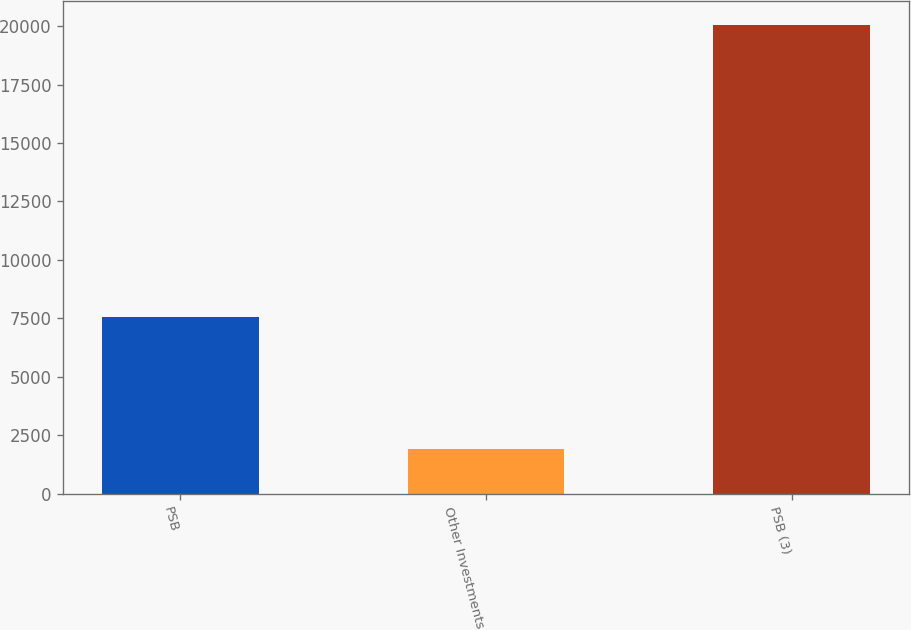Convert chart. <chart><loc_0><loc_0><loc_500><loc_500><bar_chart><fcel>PSB<fcel>Other Investments<fcel>PSB (3)<nl><fcel>7542<fcel>1913<fcel>20070<nl></chart> 